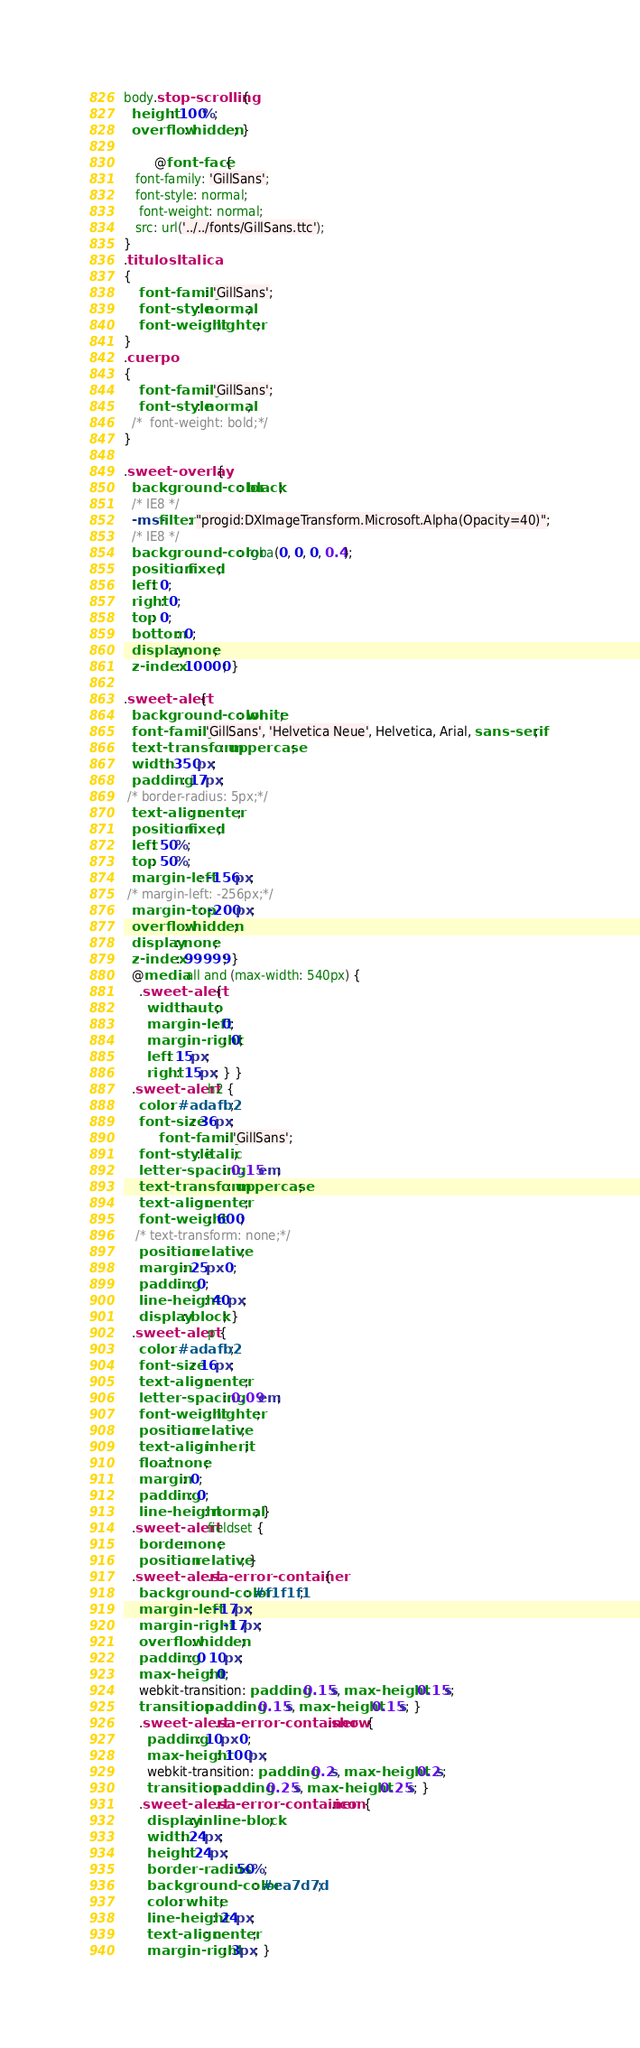<code> <loc_0><loc_0><loc_500><loc_500><_CSS_>body.stop-scrolling {
  height: 100%;
  overflow: hidden; }

  		@font-face {
   font-family: 'GillSans';
   font-style: normal;
	font-weight: normal;
   src: url('../../fonts/GillSans.ttc');
}
.titulosItalica
{
	font-family: 'GillSans';
    font-style: normal;
    font-weight: lighter;
}
.cuerpo
{
	font-family: 'GillSans';
    font-style: normal;
  /*  font-weight: bold;*/
}

.sweet-overlay {
  background-color: black;
  /* IE8 */
  -ms-filter: "progid:DXImageTransform.Microsoft.Alpha(Opacity=40)";
  /* IE8 */
  background-color: rgba(0, 0, 0, 0.4);
  position: fixed;
  left: 0;
  right: 0;
  top: 0;
  bottom: 0;
  display: none;
  z-index: 10000; }

.sweet-alert {
  background-color: white;
  font-family: 'GillSans', 'Helvetica Neue', Helvetica, Arial, sans-serif;
  text-transform: uppercase;
  width: 350px;
  padding: 17px;
 /* border-radius: 5px;*/
  text-align: center;
  position: fixed;
  left: 50%;
  top: 50%;
  margin-left: -156px;
 /* margin-left: -256px;*/
  margin-top: -200px;
  overflow: hidden;
  display: none;
  z-index: 99999; }
  @media all and (max-width: 540px) {
    .sweet-alert {
      width: auto;
      margin-left: 0;
      margin-right: 0;
      left: 15px;
      right: 15px; } }
  .sweet-alert h2 {
    color: #adafb2;
    font-size: 36px;
	     font-family: 'GillSans';
    font-style: italic;
    letter-spacing: 0.15em;
    text-transform: uppercase;
    text-align: center;
    font-weight: 600;
   /* text-transform: none;*/
    position: relative;
    margin: 25px 0;
    padding: 0;
    line-height: 40px;
    display: block; }
  .sweet-alert p {
    color: #adafb2;
    font-size: 16px;
    text-align: center;
	letter-spacing: 0.09em;
    font-weight: lighter;
    position: relative;
    text-align: inherit;
    float: none;
    margin: 0;
    padding: 0;
    line-height: normal; }
  .sweet-alert fieldset {
    border: none;
    position: relative; }
  .sweet-alert .sa-error-container {
    background-color: #f1f1f1;
    margin-left: -17px;
    margin-right: -17px;
    overflow: hidden;
    padding: 0 10px;
    max-height: 0;
    webkit-transition: padding 0.15s, max-height 0.15s;
    transition: padding 0.15s, max-height 0.15s; }
    .sweet-alert .sa-error-container.show {
      padding: 10px 0;
      max-height: 100px;
      webkit-transition: padding 0.2s, max-height 0.2s;
      transition: padding 0.25s, max-height 0.25s; }
    .sweet-alert .sa-error-container .icon {
      display: inline-block;
      width: 24px;
      height: 24px;
      border-radius: 50%;
      background-color: #ea7d7d;
      color: white;
      line-height: 24px;
      text-align: center;
      margin-right: 3px; }</code> 